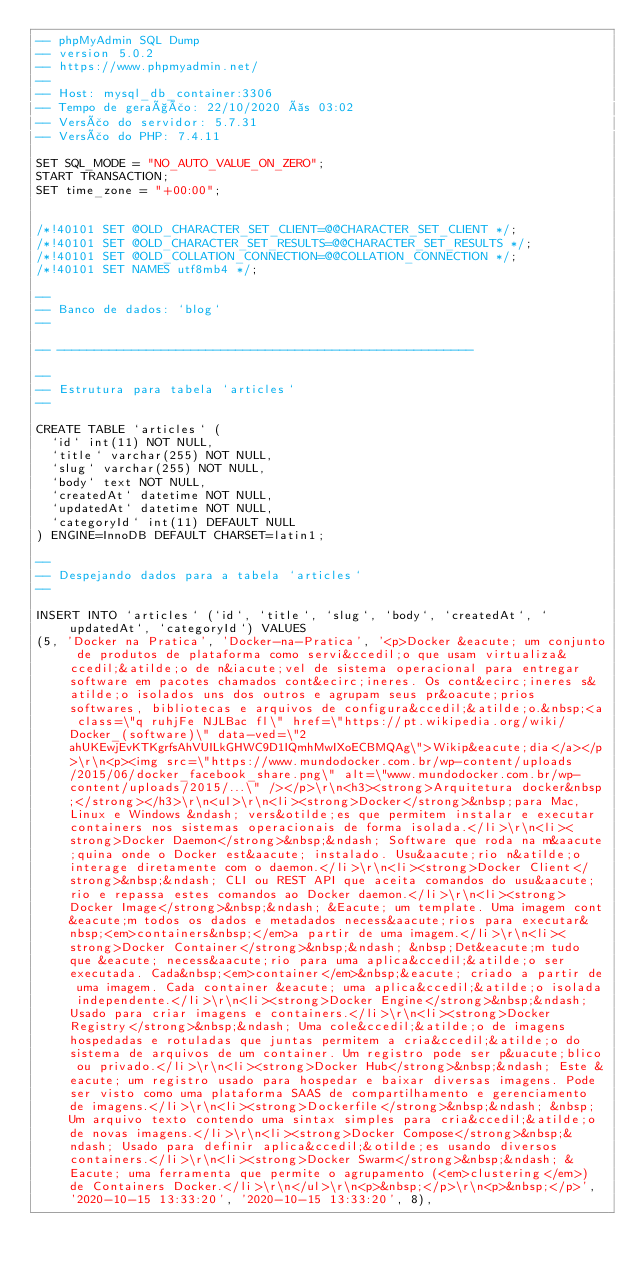<code> <loc_0><loc_0><loc_500><loc_500><_SQL_>-- phpMyAdmin SQL Dump
-- version 5.0.2
-- https://www.phpmyadmin.net/
--
-- Host: mysql_db_container:3306
-- Tempo de geração: 22/10/2020 às 03:02
-- Versão do servidor: 5.7.31
-- Versão do PHP: 7.4.11

SET SQL_MODE = "NO_AUTO_VALUE_ON_ZERO";
START TRANSACTION;
SET time_zone = "+00:00";


/*!40101 SET @OLD_CHARACTER_SET_CLIENT=@@CHARACTER_SET_CLIENT */;
/*!40101 SET @OLD_CHARACTER_SET_RESULTS=@@CHARACTER_SET_RESULTS */;
/*!40101 SET @OLD_COLLATION_CONNECTION=@@COLLATION_CONNECTION */;
/*!40101 SET NAMES utf8mb4 */;

--
-- Banco de dados: `blog`
--

-- --------------------------------------------------------

--
-- Estrutura para tabela `articles`
--

CREATE TABLE `articles` (
  `id` int(11) NOT NULL,
  `title` varchar(255) NOT NULL,
  `slug` varchar(255) NOT NULL,
  `body` text NOT NULL,
  `createdAt` datetime NOT NULL,
  `updatedAt` datetime NOT NULL,
  `categoryId` int(11) DEFAULT NULL
) ENGINE=InnoDB DEFAULT CHARSET=latin1;

--
-- Despejando dados para a tabela `articles`
--

INSERT INTO `articles` (`id`, `title`, `slug`, `body`, `createdAt`, `updatedAt`, `categoryId`) VALUES
(5, 'Docker na Pratica', 'Docker-na-Pratica', '<p>Docker &eacute; um conjunto de produtos de plataforma como servi&ccedil;o que usam virtualiza&ccedil;&atilde;o de n&iacute;vel de sistema operacional para entregar software em pacotes chamados cont&ecirc;ineres. Os cont&ecirc;ineres s&atilde;o isolados uns dos outros e agrupam seus pr&oacute;prios softwares, bibliotecas e arquivos de configura&ccedil;&atilde;o.&nbsp;<a class=\"q ruhjFe NJLBac fl\" href=\"https://pt.wikipedia.org/wiki/Docker_(software)\" data-ved=\"2ahUKEwjEvKTKgrfsAhVUILkGHWC9D1IQmhMwIXoECBMQAg\">Wikip&eacute;dia</a></p>\r\n<p><img src=\"https://www.mundodocker.com.br/wp-content/uploads/2015/06/docker_facebook_share.png\" alt=\"www.mundodocker.com.br/wp-content/uploads/2015/...\" /></p>\r\n<h3><strong>Arquitetura docker&nbsp;</strong></h3>\r\n<ul>\r\n<li><strong>Docker</strong>&nbsp;para Mac, Linux e Windows &ndash; vers&otilde;es que permitem instalar e executar containers nos sistemas operacionais de forma isolada.</li>\r\n<li><strong>Docker Daemon</strong>&nbsp;&ndash; Software que roda na m&aacute;quina onde o Docker est&aacute; instalado. Usu&aacute;rio n&atilde;o interage diretamente com o daemon.</li>\r\n<li><strong>Docker Client</strong>&nbsp;&ndash; CLI ou REST API que aceita comandos do usu&aacute;rio e repassa estes comandos ao Docker daemon.</li>\r\n<li><strong>Docker Image</strong>&nbsp;&ndash; &Eacute; um template. Uma imagem cont&eacute;m todos os dados e metadados necess&aacute;rios para executar&nbsp;<em>containers&nbsp;</em>a partir de uma imagem.</li>\r\n<li><strong>Docker Container</strong>&nbsp;&ndash; &nbsp;Det&eacute;m tudo que &eacute; necess&aacute;rio para uma aplica&ccedil;&atilde;o ser executada. Cada&nbsp;<em>container</em>&nbsp;&eacute; criado a partir de uma imagem. Cada container &eacute; uma aplica&ccedil;&atilde;o isolada independente.</li>\r\n<li><strong>Docker Engine</strong>&nbsp;&ndash; Usado para criar imagens e containers.</li>\r\n<li><strong>Docker Registry</strong>&nbsp;&ndash; Uma cole&ccedil;&atilde;o de imagens hospedadas e rotuladas que juntas permitem a cria&ccedil;&atilde;o do sistema de arquivos de um container. Um registro pode ser p&uacute;blico ou privado.</li>\r\n<li><strong>Docker Hub</strong>&nbsp;&ndash; Este &eacute; um registro usado para hospedar e baixar diversas imagens. Pode ser visto como uma plataforma SAAS de compartilhamento e gerenciamento de imagens.</li>\r\n<li><strong>Dockerfile</strong>&nbsp;&ndash; &nbsp;Um arquivo texto contendo uma sintax simples para cria&ccedil;&atilde;o de novas imagens.</li>\r\n<li><strong>Docker Compose</strong>&nbsp;&ndash; Usado para definir aplica&ccedil;&otilde;es usando diversos containers.</li>\r\n<li><strong>Docker Swarm</strong>&nbsp;&ndash; &Eacute; uma ferramenta que permite o agrupamento (<em>clustering</em>) de Containers Docker.</li>\r\n</ul>\r\n<p>&nbsp;</p>\r\n<p>&nbsp;</p>', '2020-10-15 13:33:20', '2020-10-15 13:33:20', 8),</code> 